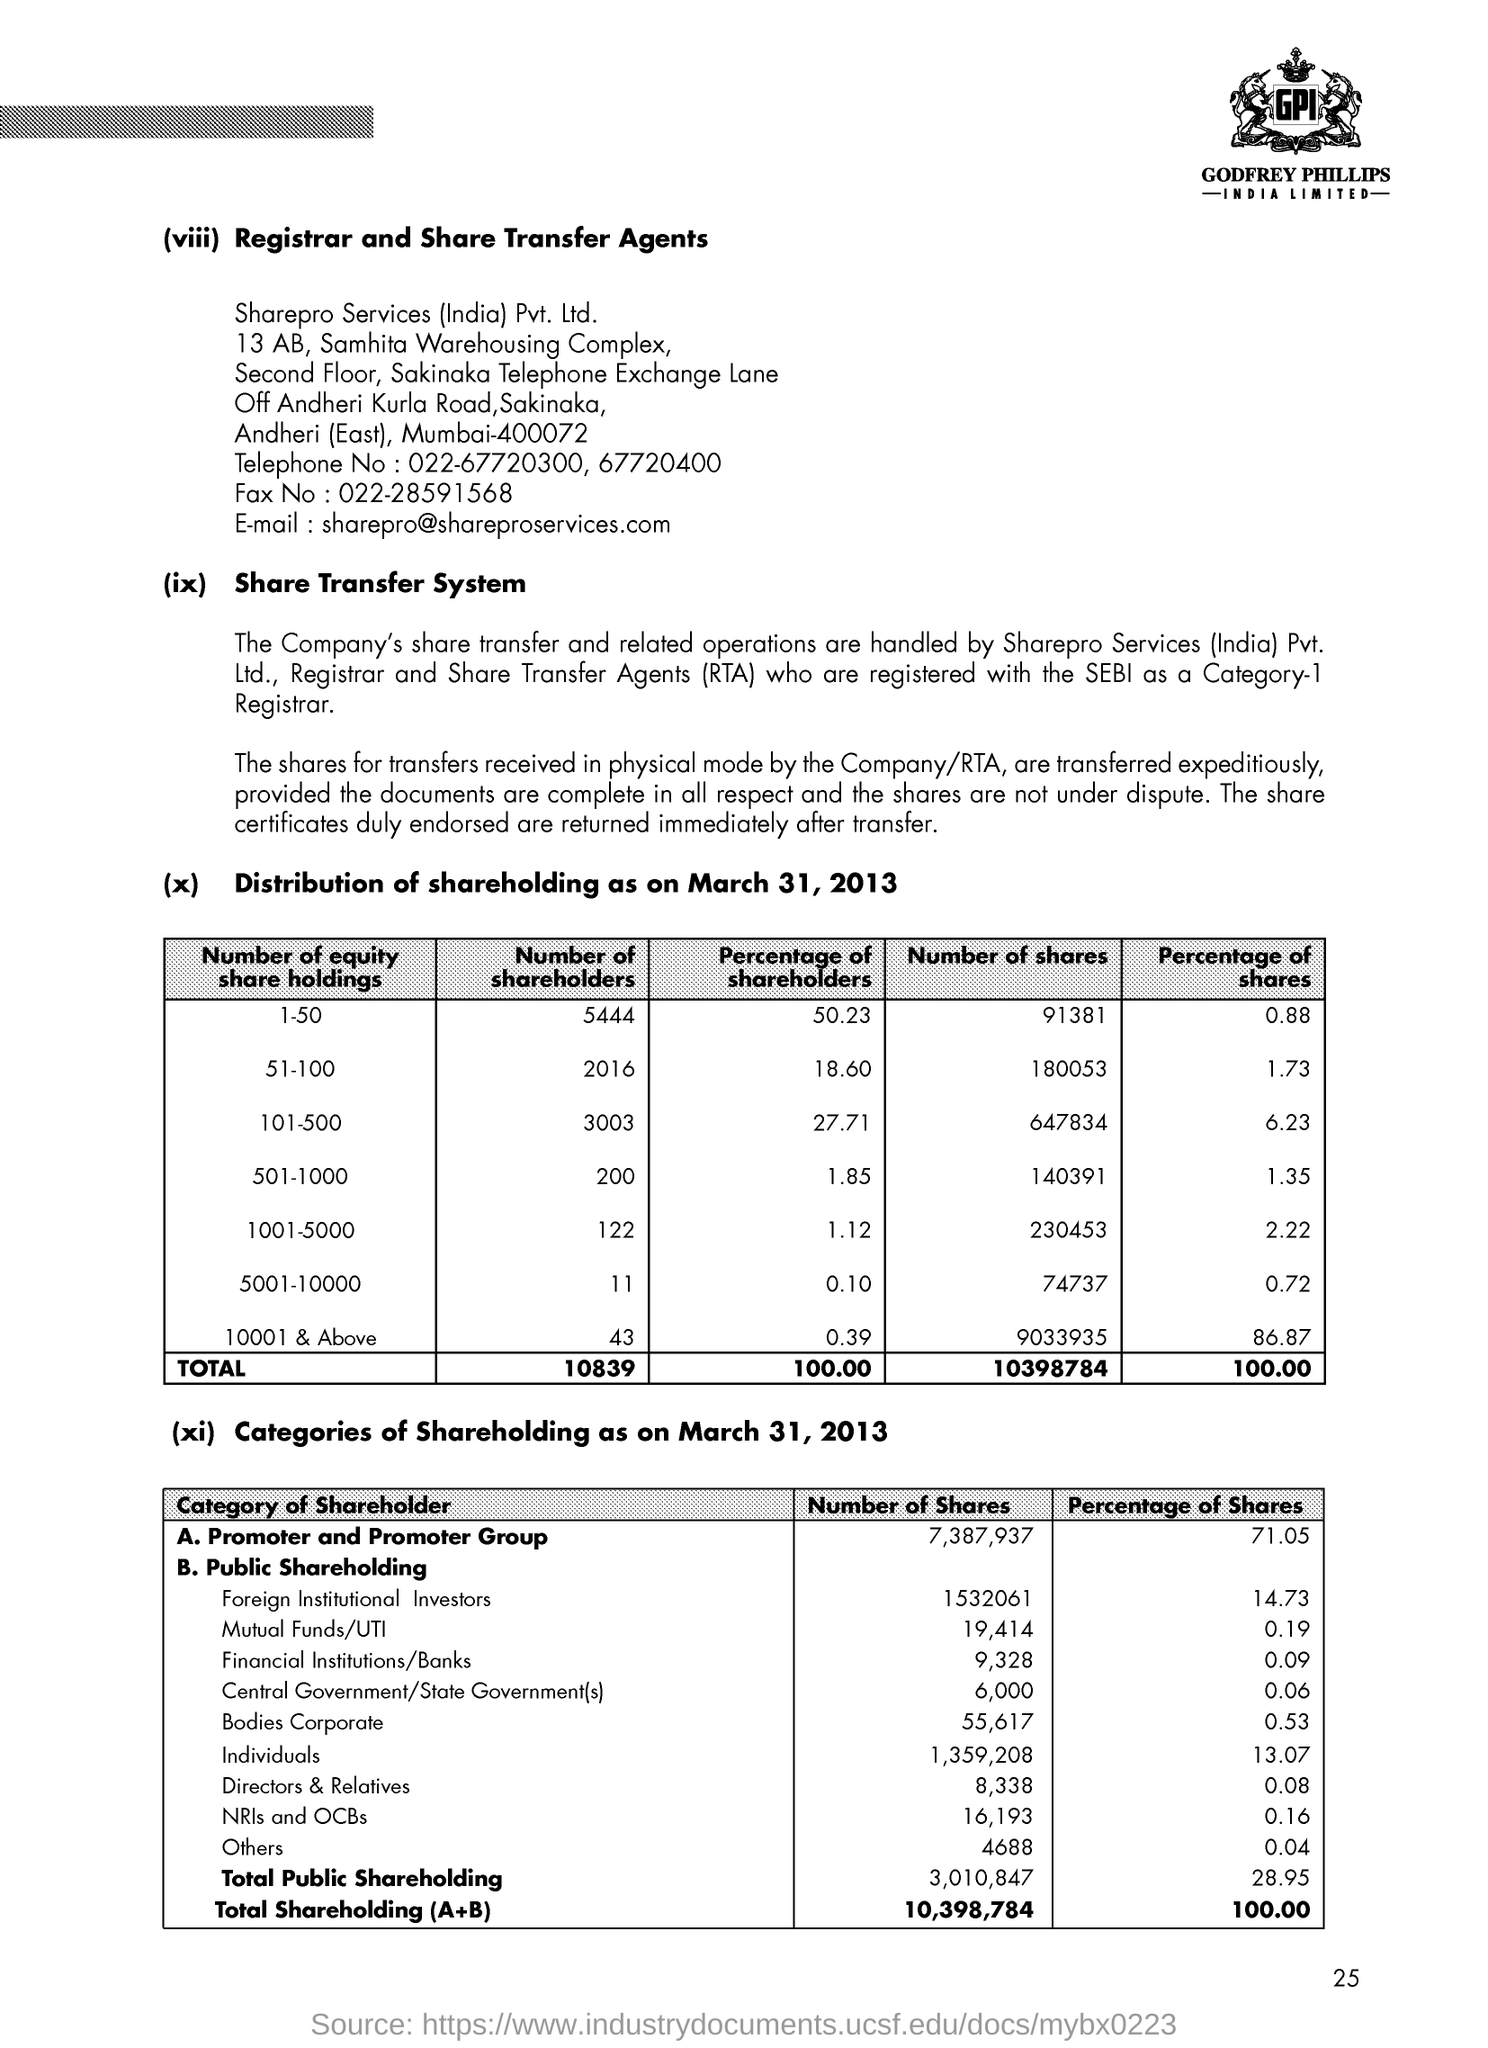Outline some significant characteristics in this image. The full form of RTA is Registrar and Share Transfer Agents, which refers to a company or individual responsible for maintaining the records of a company's shareholder information and facilitating the transfer of shares among investors. As of March 31, 2013, the number of shares held by Non-Resident Indians (NRIs) and Other Central Bodies (OCBs) was 16,193. The percentage of shares held by foreign institutional investors as of March 31, 2013 was 14.73%. As of March 31, 2013, the number of shares held by the promoter and promoter group was 7,387,937. On March 31, 2013, the promoters and promoter group held 71.05% of the shares of the company. 